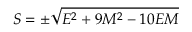Convert formula to latex. <formula><loc_0><loc_0><loc_500><loc_500>S = \pm { \sqrt { E ^ { 2 } + 9 M ^ { 2 } - 1 0 E M } }</formula> 